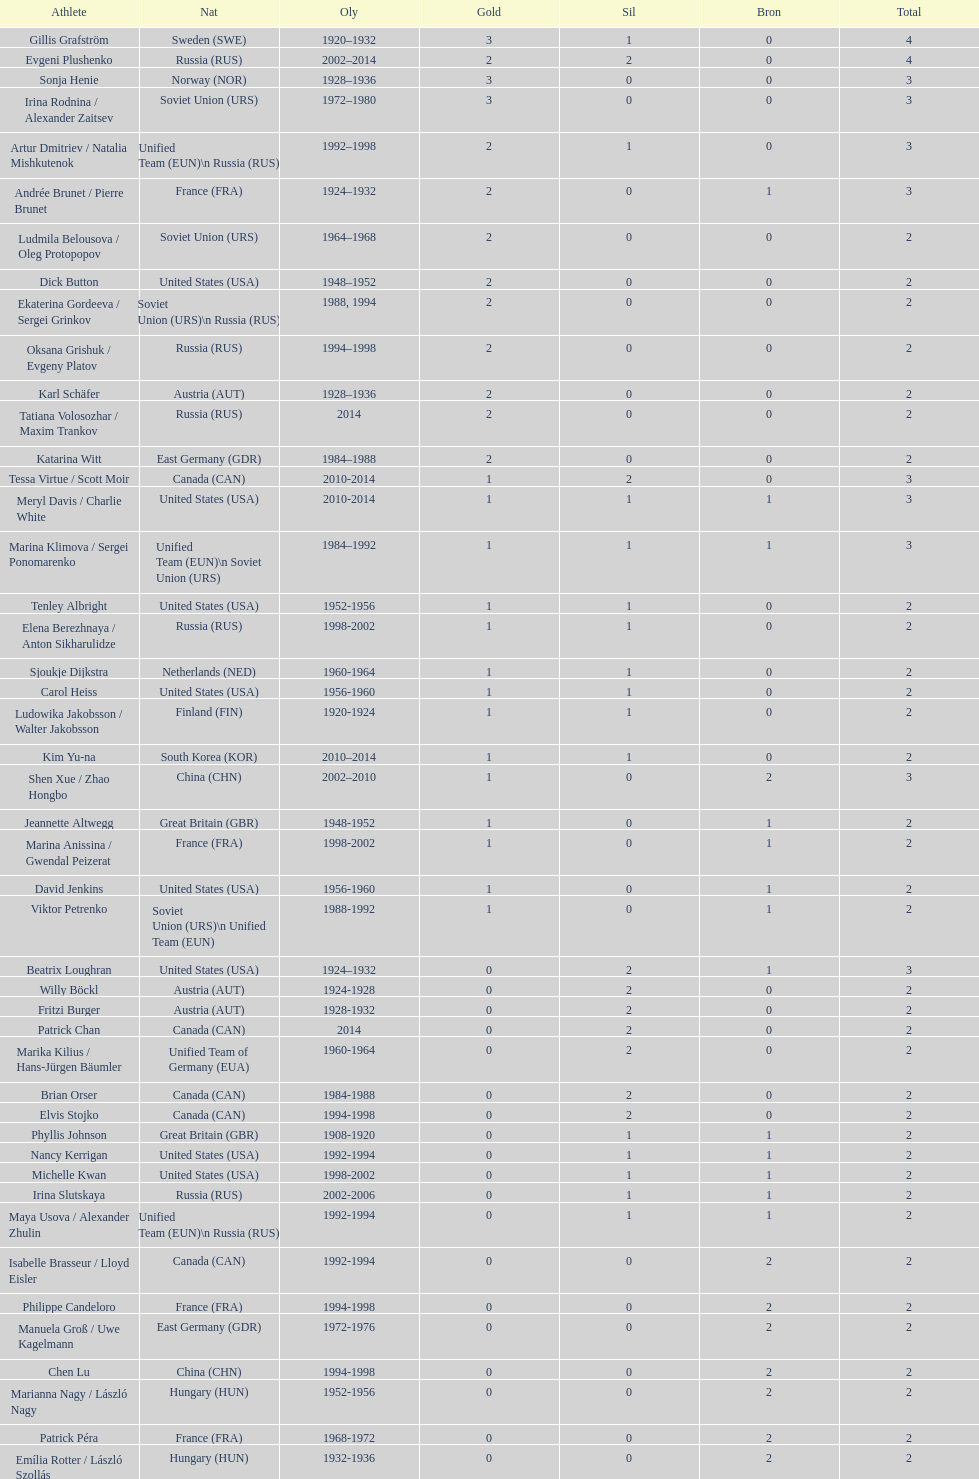Which athlete was from south korea after the year 2010? Kim Yu-na. Write the full table. {'header': ['Athlete', 'Nat', 'Oly', 'Gold', 'Sil', 'Bron', 'Total'], 'rows': [['Gillis Grafström', 'Sweden\xa0(SWE)', '1920–1932', '3', '1', '0', '4'], ['Evgeni Plushenko', 'Russia\xa0(RUS)', '2002–2014', '2', '2', '0', '4'], ['Sonja Henie', 'Norway\xa0(NOR)', '1928–1936', '3', '0', '0', '3'], ['Irina Rodnina / Alexander Zaitsev', 'Soviet Union\xa0(URS)', '1972–1980', '3', '0', '0', '3'], ['Artur Dmitriev / Natalia Mishkutenok', 'Unified Team\xa0(EUN)\\n\xa0Russia\xa0(RUS)', '1992–1998', '2', '1', '0', '3'], ['Andrée Brunet / Pierre Brunet', 'France\xa0(FRA)', '1924–1932', '2', '0', '1', '3'], ['Ludmila Belousova / Oleg Protopopov', 'Soviet Union\xa0(URS)', '1964–1968', '2', '0', '0', '2'], ['Dick Button', 'United States\xa0(USA)', '1948–1952', '2', '0', '0', '2'], ['Ekaterina Gordeeva / Sergei Grinkov', 'Soviet Union\xa0(URS)\\n\xa0Russia\xa0(RUS)', '1988, 1994', '2', '0', '0', '2'], ['Oksana Grishuk / Evgeny Platov', 'Russia\xa0(RUS)', '1994–1998', '2', '0', '0', '2'], ['Karl Schäfer', 'Austria\xa0(AUT)', '1928–1936', '2', '0', '0', '2'], ['Tatiana Volosozhar / Maxim Trankov', 'Russia\xa0(RUS)', '2014', '2', '0', '0', '2'], ['Katarina Witt', 'East Germany\xa0(GDR)', '1984–1988', '2', '0', '0', '2'], ['Tessa Virtue / Scott Moir', 'Canada\xa0(CAN)', '2010-2014', '1', '2', '0', '3'], ['Meryl Davis / Charlie White', 'United States\xa0(USA)', '2010-2014', '1', '1', '1', '3'], ['Marina Klimova / Sergei Ponomarenko', 'Unified Team\xa0(EUN)\\n\xa0Soviet Union\xa0(URS)', '1984–1992', '1', '1', '1', '3'], ['Tenley Albright', 'United States\xa0(USA)', '1952-1956', '1', '1', '0', '2'], ['Elena Berezhnaya / Anton Sikharulidze', 'Russia\xa0(RUS)', '1998-2002', '1', '1', '0', '2'], ['Sjoukje Dijkstra', 'Netherlands\xa0(NED)', '1960-1964', '1', '1', '0', '2'], ['Carol Heiss', 'United States\xa0(USA)', '1956-1960', '1', '1', '0', '2'], ['Ludowika Jakobsson / Walter Jakobsson', 'Finland\xa0(FIN)', '1920-1924', '1', '1', '0', '2'], ['Kim Yu-na', 'South Korea\xa0(KOR)', '2010–2014', '1', '1', '0', '2'], ['Shen Xue / Zhao Hongbo', 'China\xa0(CHN)', '2002–2010', '1', '0', '2', '3'], ['Jeannette Altwegg', 'Great Britain\xa0(GBR)', '1948-1952', '1', '0', '1', '2'], ['Marina Anissina / Gwendal Peizerat', 'France\xa0(FRA)', '1998-2002', '1', '0', '1', '2'], ['David Jenkins', 'United States\xa0(USA)', '1956-1960', '1', '0', '1', '2'], ['Viktor Petrenko', 'Soviet Union\xa0(URS)\\n\xa0Unified Team\xa0(EUN)', '1988-1992', '1', '0', '1', '2'], ['Beatrix Loughran', 'United States\xa0(USA)', '1924–1932', '0', '2', '1', '3'], ['Willy Böckl', 'Austria\xa0(AUT)', '1924-1928', '0', '2', '0', '2'], ['Fritzi Burger', 'Austria\xa0(AUT)', '1928-1932', '0', '2', '0', '2'], ['Patrick Chan', 'Canada\xa0(CAN)', '2014', '0', '2', '0', '2'], ['Marika Kilius / Hans-Jürgen Bäumler', 'Unified Team of Germany\xa0(EUA)', '1960-1964', '0', '2', '0', '2'], ['Brian Orser', 'Canada\xa0(CAN)', '1984-1988', '0', '2', '0', '2'], ['Elvis Stojko', 'Canada\xa0(CAN)', '1994-1998', '0', '2', '0', '2'], ['Phyllis Johnson', 'Great Britain\xa0(GBR)', '1908-1920', '0', '1', '1', '2'], ['Nancy Kerrigan', 'United States\xa0(USA)', '1992-1994', '0', '1', '1', '2'], ['Michelle Kwan', 'United States\xa0(USA)', '1998-2002', '0', '1', '1', '2'], ['Irina Slutskaya', 'Russia\xa0(RUS)', '2002-2006', '0', '1', '1', '2'], ['Maya Usova / Alexander Zhulin', 'Unified Team\xa0(EUN)\\n\xa0Russia\xa0(RUS)', '1992-1994', '0', '1', '1', '2'], ['Isabelle Brasseur / Lloyd Eisler', 'Canada\xa0(CAN)', '1992-1994', '0', '0', '2', '2'], ['Philippe Candeloro', 'France\xa0(FRA)', '1994-1998', '0', '0', '2', '2'], ['Manuela Groß / Uwe Kagelmann', 'East Germany\xa0(GDR)', '1972-1976', '0', '0', '2', '2'], ['Chen Lu', 'China\xa0(CHN)', '1994-1998', '0', '0', '2', '2'], ['Marianna Nagy / László Nagy', 'Hungary\xa0(HUN)', '1952-1956', '0', '0', '2', '2'], ['Patrick Péra', 'France\xa0(FRA)', '1968-1972', '0', '0', '2', '2'], ['Emília Rotter / László Szollás', 'Hungary\xa0(HUN)', '1932-1936', '0', '0', '2', '2'], ['Aliona Savchenko / Robin Szolkowy', 'Germany\xa0(GER)', '2010-2014', '0', '0', '2', '2']]} 